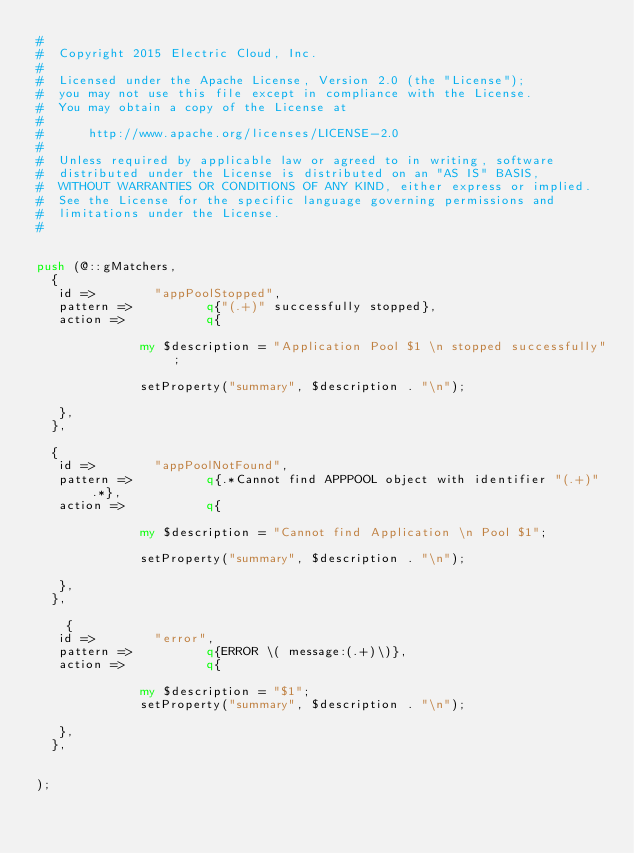Convert code to text. <code><loc_0><loc_0><loc_500><loc_500><_Perl_>#
#  Copyright 2015 Electric Cloud, Inc.
#
#  Licensed under the Apache License, Version 2.0 (the "License");
#  you may not use this file except in compliance with the License.
#  You may obtain a copy of the License at
#
#      http://www.apache.org/licenses/LICENSE-2.0
#
#  Unless required by applicable law or agreed to in writing, software
#  distributed under the License is distributed on an "AS IS" BASIS,
#  WITHOUT WARRANTIES OR CONDITIONS OF ANY KIND, either express or implied.
#  See the License for the specific language governing permissions and
#  limitations under the License.
#


push (@::gMatchers,
  {
   id =>        "appPoolStopped",
   pattern =>          q{"(.+)" successfully stopped},
   action =>           q{
    
              my $description = "Application Pool $1 \n stopped successfully";
                              
              setProperty("summary", $description . "\n");
    
   },
  },
  
  {
   id =>        "appPoolNotFound",
   pattern =>          q{.*Cannot find APPPOOL object with identifier "(.+)".*},
   action =>           q{
    
              my $description = "Cannot find Application \n Pool $1";
                              
              setProperty("summary", $description . "\n");
    
   },
  },
  
    {
   id =>        "error",
   pattern =>          q{ERROR \( message:(.+)\)},
   action =>           q{
    
              my $description = "$1";
              setProperty("summary", $description . "\n");
    
   },
  },
  
 
);

</code> 